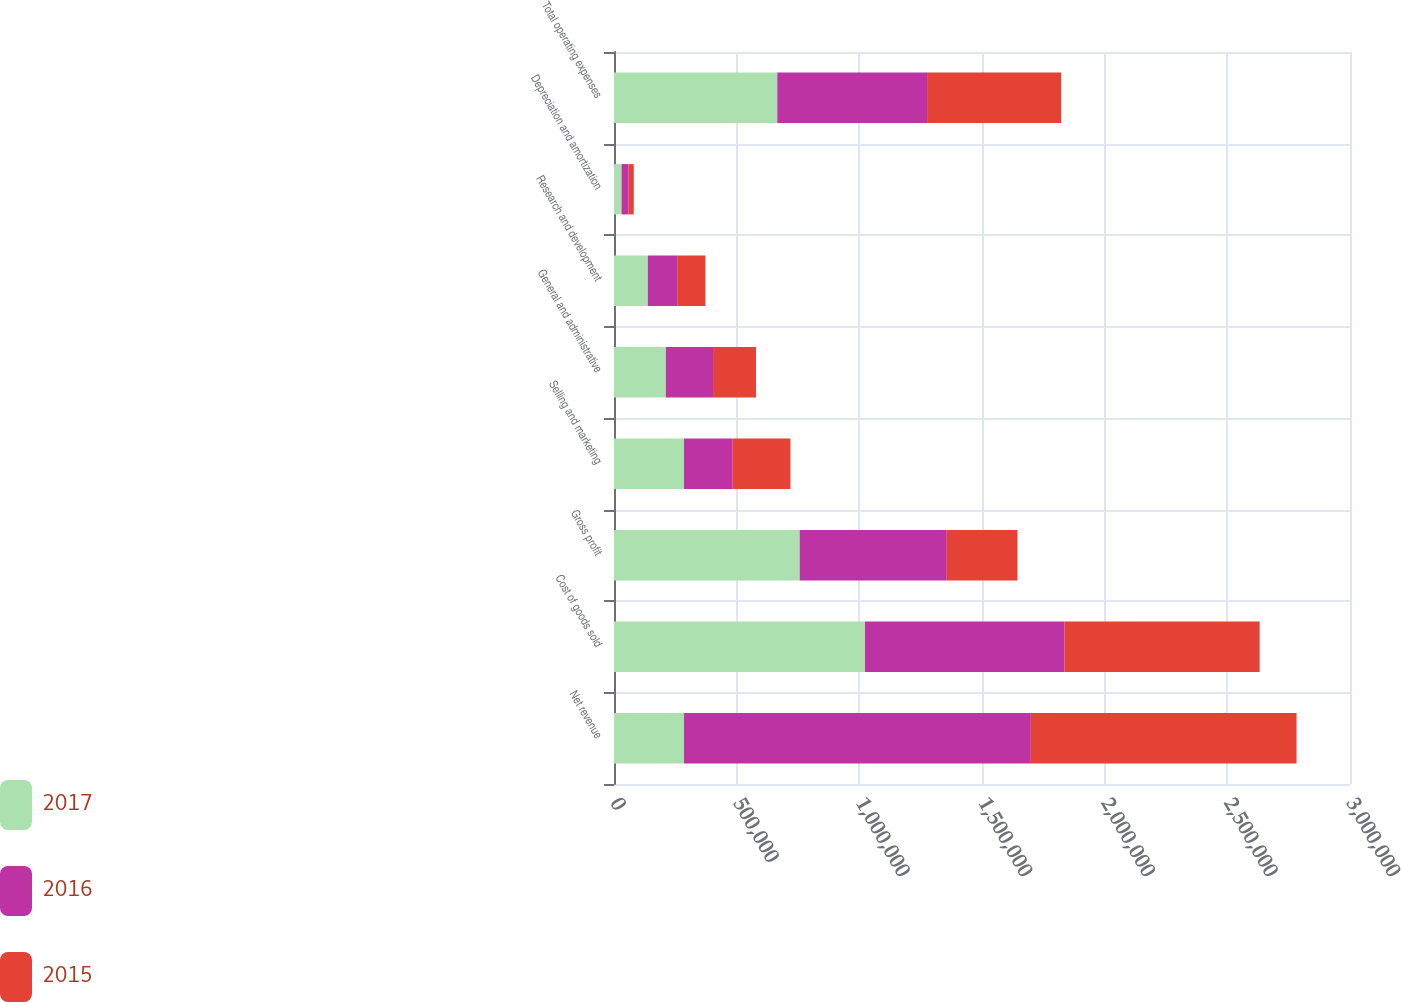Convert chart. <chart><loc_0><loc_0><loc_500><loc_500><stacked_bar_chart><ecel><fcel>Net revenue<fcel>Cost of goods sold<fcel>Gross profit<fcel>Selling and marketing<fcel>General and administrative<fcel>Research and development<fcel>Depreciation and amortization<fcel>Total operating expenses<nl><fcel>2017<fcel>285453<fcel>1.02296e+06<fcel>756789<fcel>285453<fcel>211409<fcel>137915<fcel>30707<fcel>665484<nl><fcel>2016<fcel>1.4137e+06<fcel>813873<fcel>599825<fcel>198309<fcel>192452<fcel>119807<fcel>28800<fcel>610653<nl><fcel>2015<fcel>1.08294e+06<fcel>794867<fcel>288071<fcel>235341<fcel>175093<fcel>115043<fcel>21057<fcel>546534<nl></chart> 